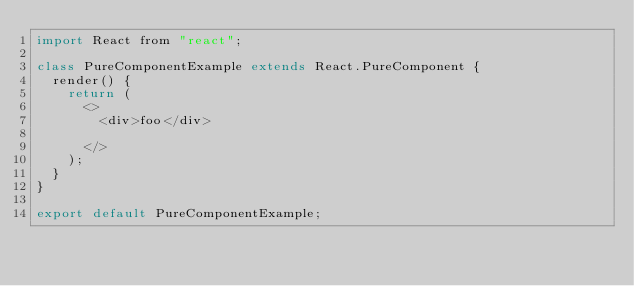Convert code to text. <code><loc_0><loc_0><loc_500><loc_500><_JavaScript_>import React from "react";

class PureComponentExample extends React.PureComponent {
  render() {
    return (
      <>
        <div>foo</div>
        
      </>
    );
  }
}

export default PureComponentExample;
</code> 